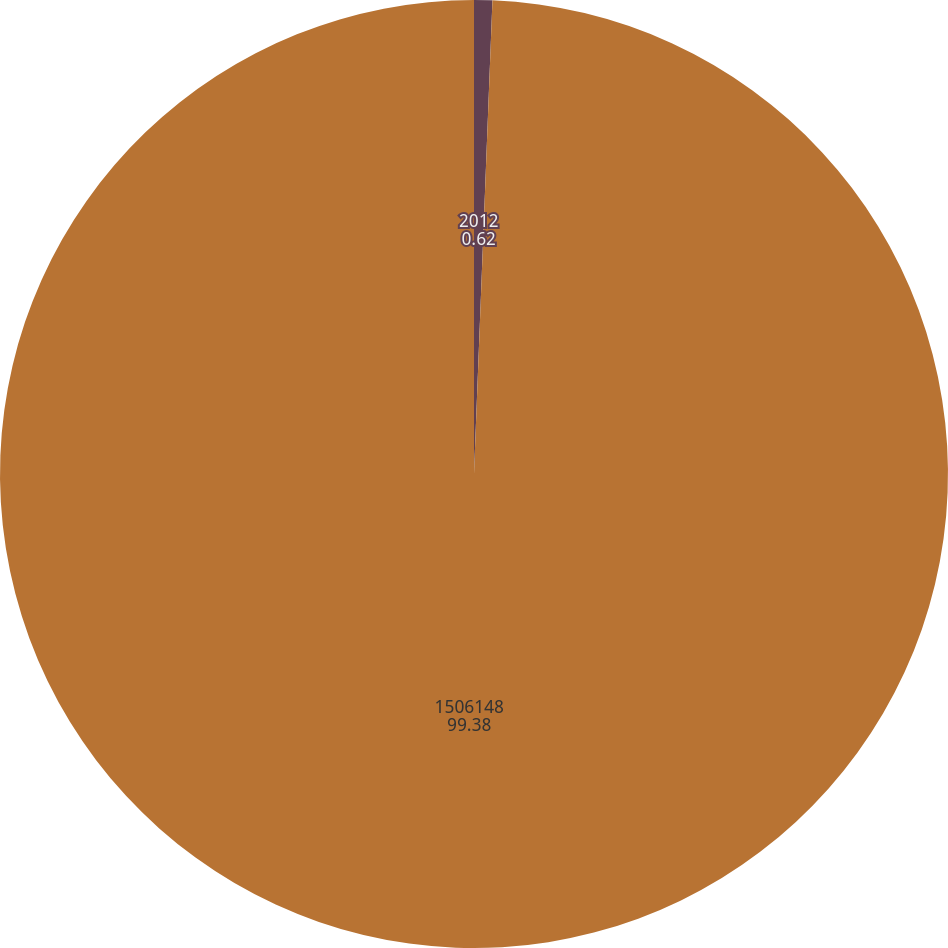Convert chart to OTSL. <chart><loc_0><loc_0><loc_500><loc_500><pie_chart><fcel>2012<fcel>1506148<nl><fcel>0.62%<fcel>99.38%<nl></chart> 